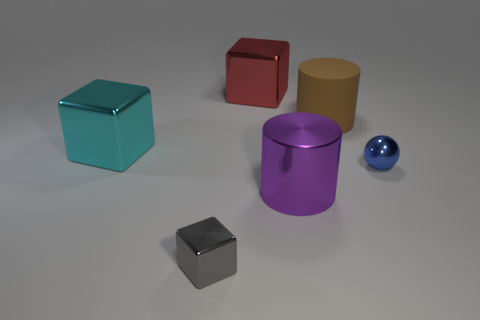Are there any small shiny balls of the same color as the small shiny cube?
Make the answer very short. No. There is a cube that is the same size as the red thing; what is its color?
Keep it short and to the point. Cyan. There is a sphere; does it have the same color as the big cylinder in front of the big brown matte thing?
Keep it short and to the point. No. What is the color of the big matte cylinder?
Your response must be concise. Brown. What material is the tiny thing that is to the left of the big red metal object?
Provide a short and direct response. Metal. What is the size of the other thing that is the same shape as the big brown matte object?
Offer a terse response. Large. Are there fewer big cylinders on the left side of the large red shiny cube than gray blocks?
Make the answer very short. Yes. Are any gray objects visible?
Make the answer very short. Yes. There is a tiny thing that is the same shape as the large red metallic thing; what is its color?
Your response must be concise. Gray. There is a big cylinder behind the large purple shiny cylinder; is its color the same as the ball?
Make the answer very short. No. 